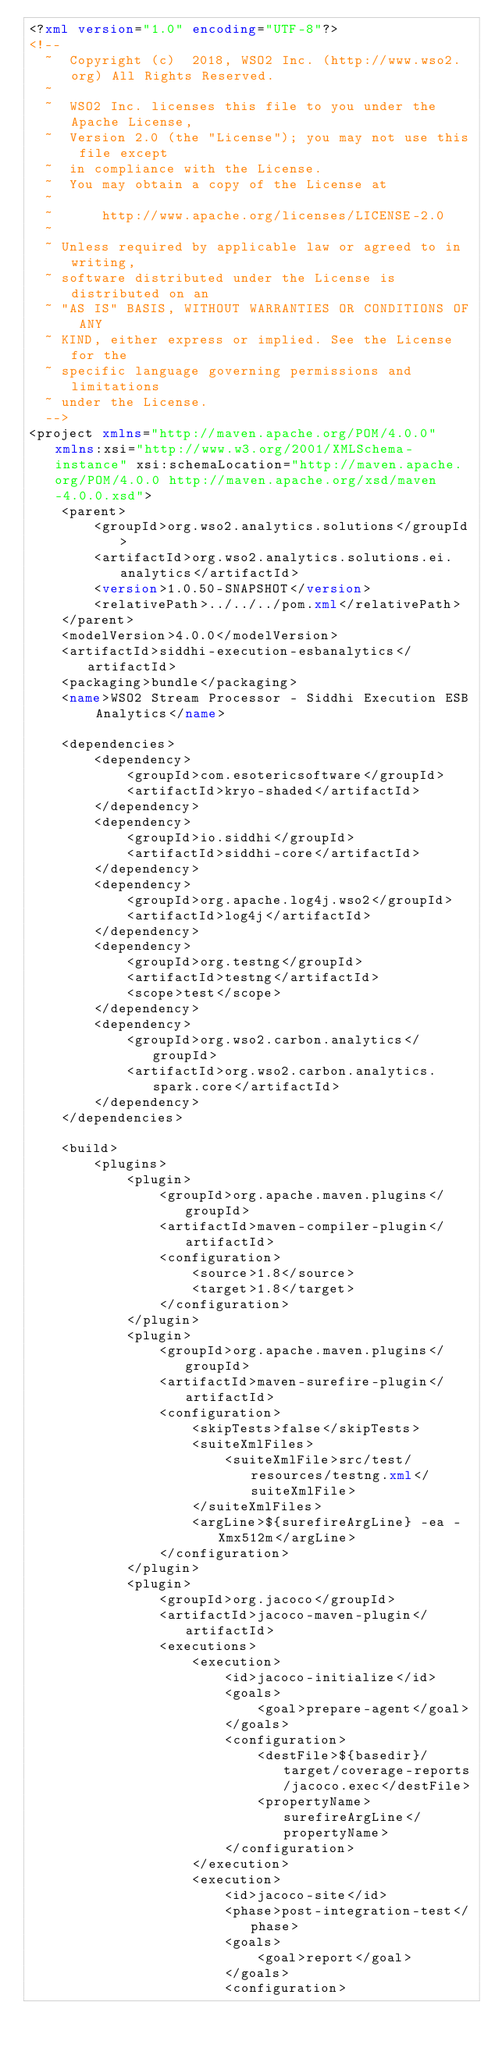Convert code to text. <code><loc_0><loc_0><loc_500><loc_500><_XML_><?xml version="1.0" encoding="UTF-8"?>
<!--
  ~  Copyright (c)  2018, WSO2 Inc. (http://www.wso2.org) All Rights Reserved.
  ~
  ~  WSO2 Inc. licenses this file to you under the Apache License,
  ~  Version 2.0 (the "License"); you may not use this file except
  ~  in compliance with the License.
  ~  You may obtain a copy of the License at
  ~
  ~      http://www.apache.org/licenses/LICENSE-2.0
  ~
  ~ Unless required by applicable law or agreed to in writing,
  ~ software distributed under the License is distributed on an
  ~ "AS IS" BASIS, WITHOUT WARRANTIES OR CONDITIONS OF ANY
  ~ KIND, either express or implied. See the License for the
  ~ specific language governing permissions and limitations
  ~ under the License.
  -->
<project xmlns="http://maven.apache.org/POM/4.0.0" xmlns:xsi="http://www.w3.org/2001/XMLSchema-instance" xsi:schemaLocation="http://maven.apache.org/POM/4.0.0 http://maven.apache.org/xsd/maven-4.0.0.xsd">
    <parent>
        <groupId>org.wso2.analytics.solutions</groupId>
        <artifactId>org.wso2.analytics.solutions.ei.analytics</artifactId>
        <version>1.0.50-SNAPSHOT</version>
        <relativePath>../../../pom.xml</relativePath>
    </parent>
    <modelVersion>4.0.0</modelVersion>
    <artifactId>siddhi-execution-esbanalytics</artifactId>
    <packaging>bundle</packaging>
    <name>WSO2 Stream Processor - Siddhi Execution ESB Analytics</name>

    <dependencies>
        <dependency>
            <groupId>com.esotericsoftware</groupId>
            <artifactId>kryo-shaded</artifactId>
        </dependency>
        <dependency>
            <groupId>io.siddhi</groupId>
            <artifactId>siddhi-core</artifactId>
        </dependency>
        <dependency>
            <groupId>org.apache.log4j.wso2</groupId>
            <artifactId>log4j</artifactId>
        </dependency>
        <dependency>
            <groupId>org.testng</groupId>
            <artifactId>testng</artifactId>
            <scope>test</scope>
        </dependency>
        <dependency>
            <groupId>org.wso2.carbon.analytics</groupId>
            <artifactId>org.wso2.carbon.analytics.spark.core</artifactId>
        </dependency>
    </dependencies>

    <build>
        <plugins>
            <plugin>
                <groupId>org.apache.maven.plugins</groupId>
                <artifactId>maven-compiler-plugin</artifactId>
                <configuration>
                    <source>1.8</source>
                    <target>1.8</target>
                </configuration>
            </plugin>
            <plugin>
                <groupId>org.apache.maven.plugins</groupId>
                <artifactId>maven-surefire-plugin</artifactId>
                <configuration>
                    <skipTests>false</skipTests>
                    <suiteXmlFiles>
                        <suiteXmlFile>src/test/resources/testng.xml</suiteXmlFile>
                    </suiteXmlFiles>
                    <argLine>${surefireArgLine} -ea -Xmx512m</argLine>
                </configuration>
            </plugin>
            <plugin>
                <groupId>org.jacoco</groupId>
                <artifactId>jacoco-maven-plugin</artifactId>
                <executions>
                    <execution>
                        <id>jacoco-initialize</id>
                        <goals>
                            <goal>prepare-agent</goal>
                        </goals>
                        <configuration>
                            <destFile>${basedir}/target/coverage-reports/jacoco.exec</destFile>
                            <propertyName>surefireArgLine</propertyName>
                        </configuration>
                    </execution>
                    <execution>
                        <id>jacoco-site</id>
                        <phase>post-integration-test</phase>
                        <goals>
                            <goal>report</goal>
                        </goals>
                        <configuration></code> 